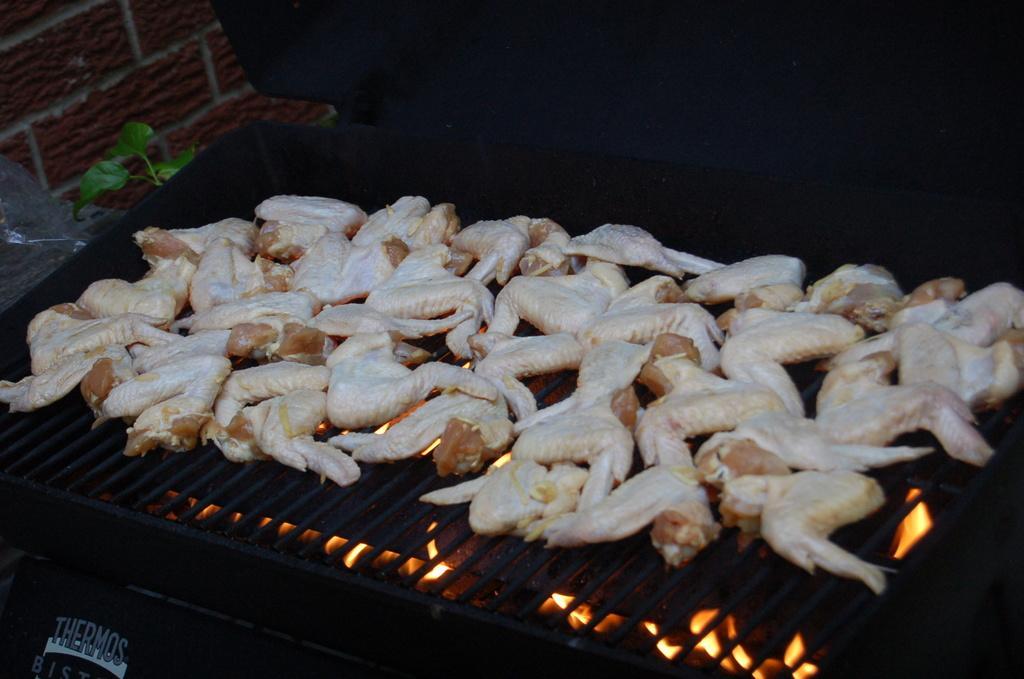Please provide a concise description of this image. In this picture we can see a barbecue grill and on the barbecue grill there are some food items. On the left side of the girl there is a plant and a wall. 